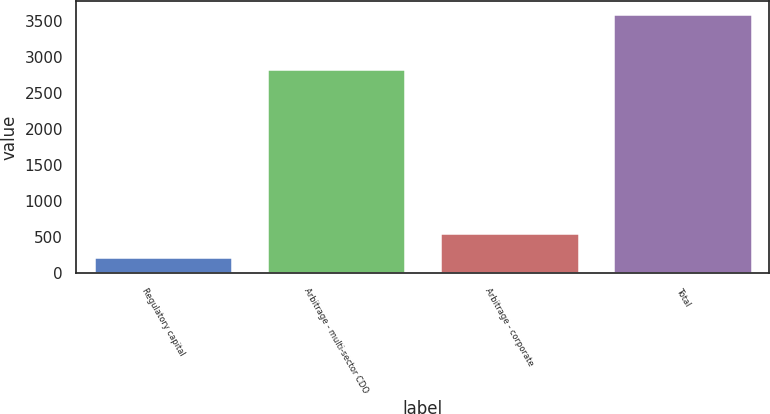Convert chart to OTSL. <chart><loc_0><loc_0><loc_500><loc_500><bar_chart><fcel>Regulatory capital<fcel>Arbitrage - multi-sector CDO<fcel>Arbitrage - corporate<fcel>Total<nl><fcel>226<fcel>2843<fcel>563<fcel>3596<nl></chart> 